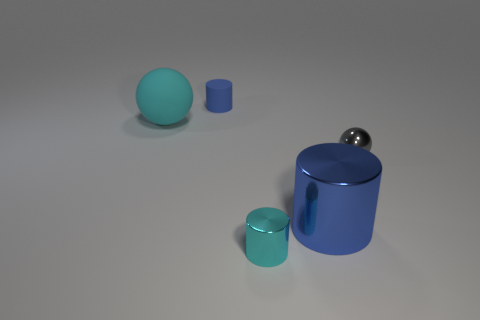What color is the large cylinder that is the same material as the gray ball?
Provide a short and direct response. Blue. Is there anything else that has the same size as the rubber sphere?
Your response must be concise. Yes. How many things are either small metal objects that are behind the large blue metal thing or metal cylinders that are behind the small cyan shiny object?
Provide a succinct answer. 2. There is a object that is in front of the blue shiny cylinder; is its size the same as the blue cylinder in front of the gray object?
Provide a succinct answer. No. The metal object that is the same shape as the big cyan rubber thing is what color?
Offer a very short reply. Gray. Is the number of tiny cylinders behind the large rubber object greater than the number of tiny blue objects that are behind the small blue cylinder?
Offer a very short reply. Yes. There is a blue cylinder to the left of the shiny cylinder left of the blue cylinder in front of the small gray thing; how big is it?
Make the answer very short. Small. Does the large ball have the same material as the tiny cylinder behind the large blue metallic cylinder?
Ensure brevity in your answer.  Yes. Is the shape of the tiny blue matte thing the same as the tiny cyan object?
Give a very brief answer. Yes. How many other objects are the same material as the tiny gray object?
Make the answer very short. 2. 